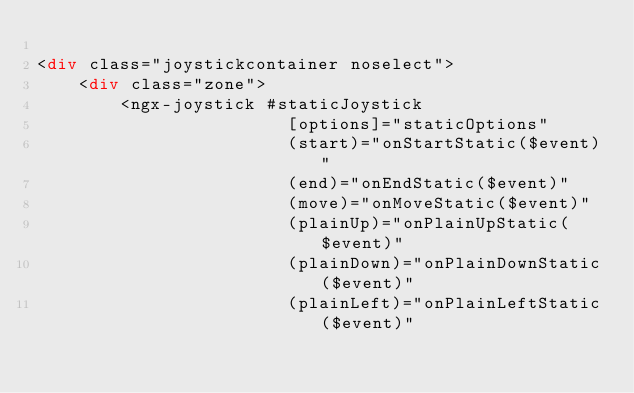<code> <loc_0><loc_0><loc_500><loc_500><_HTML_>
<div class="joystickcontainer noselect">
    <div class="zone">
        <ngx-joystick #staticJoystick
                        [options]="staticOptions"
                        (start)="onStartStatic($event)"
                        (end)="onEndStatic($event)"
                        (move)="onMoveStatic($event)"
                        (plainUp)="onPlainUpStatic($event)"
                        (plainDown)="onPlainDownStatic($event)"
                        (plainLeft)="onPlainLeftStatic($event)"</code> 